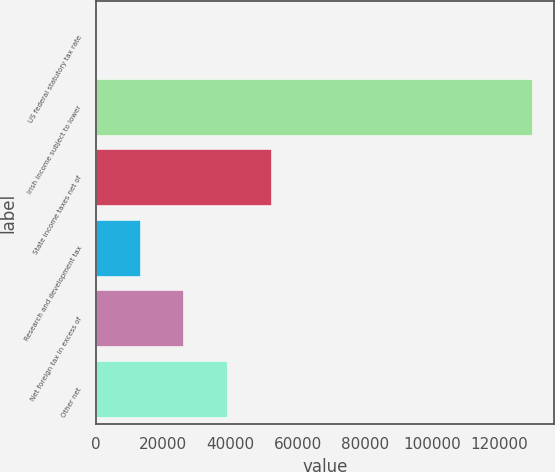Convert chart. <chart><loc_0><loc_0><loc_500><loc_500><bar_chart><fcel>US federal statutory tax rate<fcel>Irish income subject to lower<fcel>State income taxes net of<fcel>Research and development tax<fcel>Net foreign tax in excess of<fcel>Other net<nl><fcel>35<fcel>129741<fcel>51917.4<fcel>13005.6<fcel>25976.2<fcel>38946.8<nl></chart> 